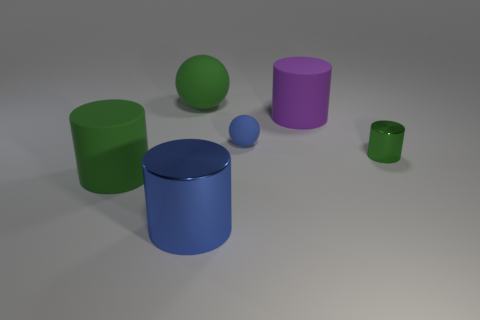What is the shape of the blue object behind the big blue cylinder in front of the green object that is behind the small green cylinder?
Your response must be concise. Sphere. What number of objects are either green rubber objects or metallic cylinders that are left of the blue rubber object?
Offer a terse response. 3. Does the green object left of the green ball have the same shape as the tiny object that is behind the small green shiny object?
Your response must be concise. No. How many things are either metal things or tiny cylinders?
Keep it short and to the point. 2. Is there a small metal cylinder?
Offer a terse response. Yes. Does the green cylinder that is to the right of the blue shiny cylinder have the same material as the purple thing?
Ensure brevity in your answer.  No. Is there a big green object of the same shape as the blue rubber object?
Offer a terse response. Yes. Are there an equal number of large purple matte cylinders that are left of the big purple cylinder and gray matte cylinders?
Your answer should be very brief. Yes. There is a cylinder that is to the right of the big rubber cylinder that is behind the green shiny cylinder; what is it made of?
Give a very brief answer. Metal. There is a tiny blue matte object; what shape is it?
Your answer should be compact. Sphere. 